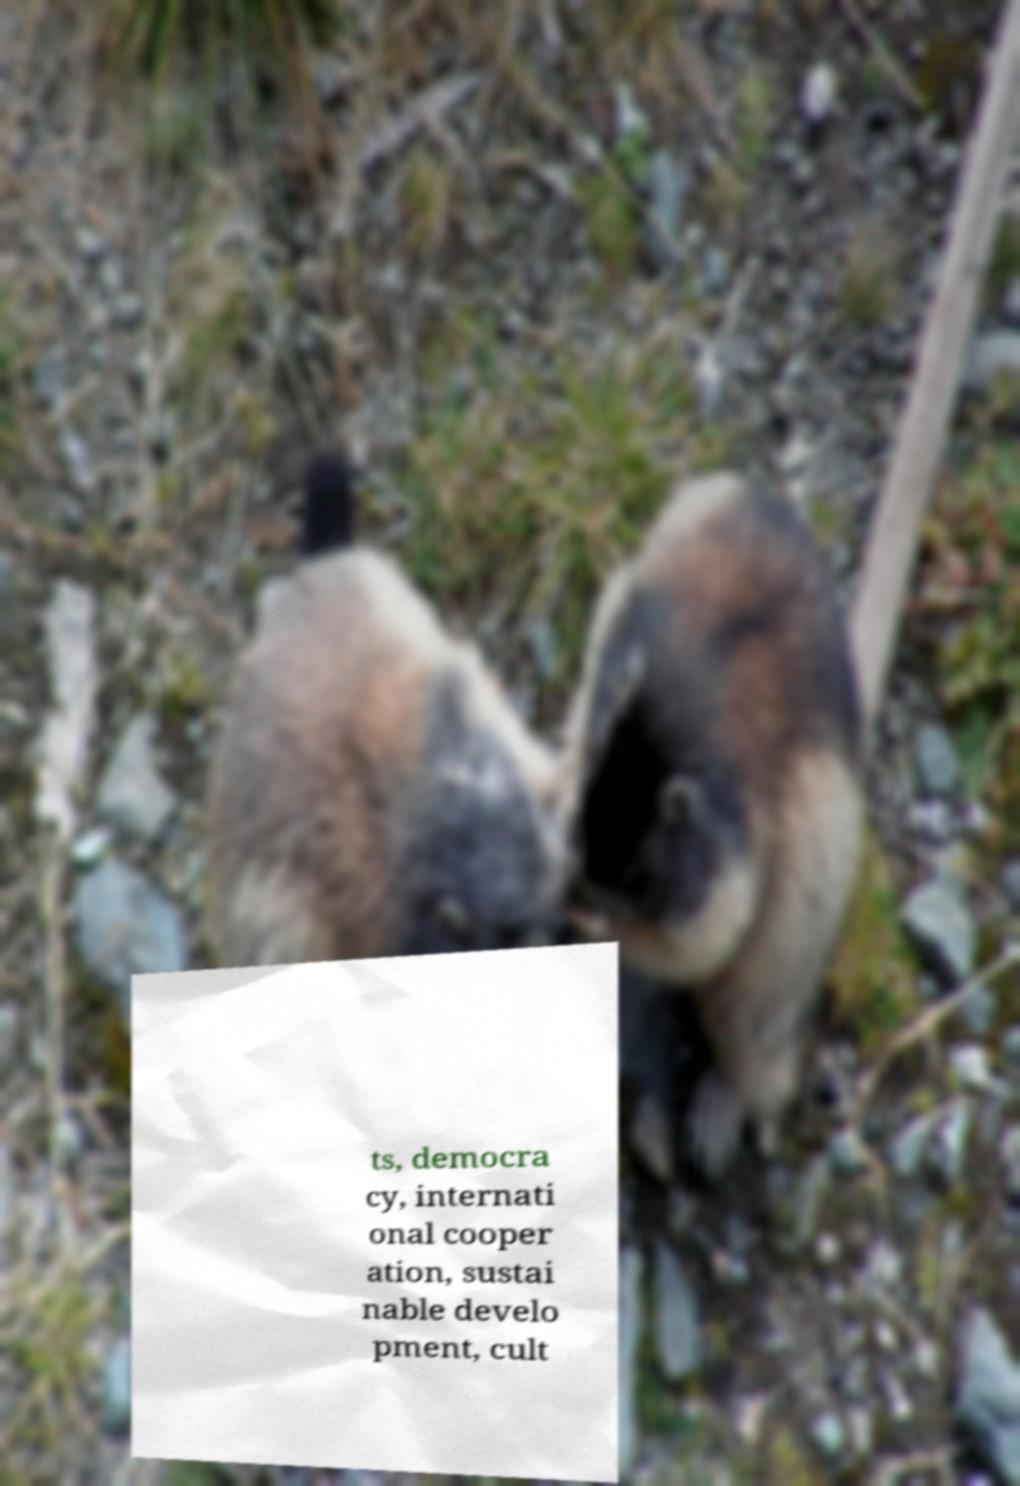Please read and relay the text visible in this image. What does it say? ts, democra cy, internati onal cooper ation, sustai nable develo pment, cult 